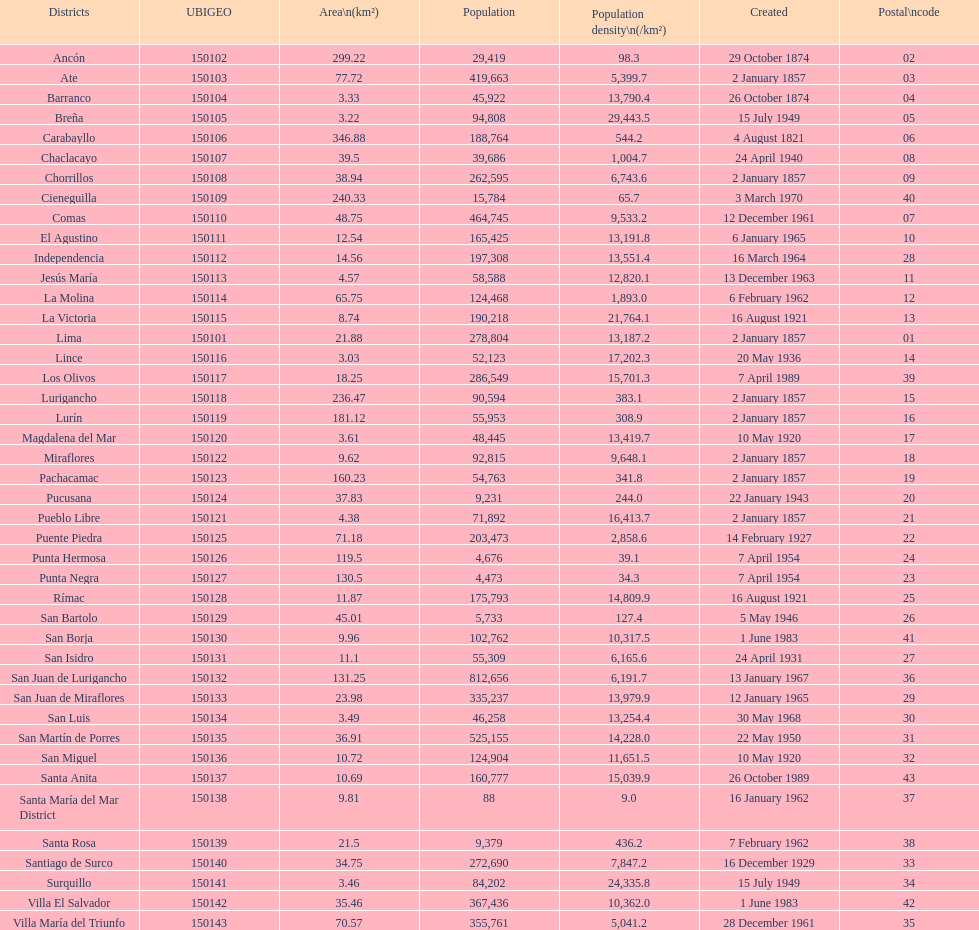I'm looking to parse the entire table for insights. Could you assist me with that? {'header': ['Districts', 'UBIGEO', 'Area\\n(km²)', 'Population', 'Population density\\n(/km²)', 'Created', 'Postal\\ncode'], 'rows': [['Ancón', '150102', '299.22', '29,419', '98.3', '29 October 1874', '02'], ['Ate', '150103', '77.72', '419,663', '5,399.7', '2 January 1857', '03'], ['Barranco', '150104', '3.33', '45,922', '13,790.4', '26 October 1874', '04'], ['Breña', '150105', '3.22', '94,808', '29,443.5', '15 July 1949', '05'], ['Carabayllo', '150106', '346.88', '188,764', '544.2', '4 August 1821', '06'], ['Chaclacayo', '150107', '39.5', '39,686', '1,004.7', '24 April 1940', '08'], ['Chorrillos', '150108', '38.94', '262,595', '6,743.6', '2 January 1857', '09'], ['Cieneguilla', '150109', '240.33', '15,784', '65.7', '3 March 1970', '40'], ['Comas', '150110', '48.75', '464,745', '9,533.2', '12 December 1961', '07'], ['El Agustino', '150111', '12.54', '165,425', '13,191.8', '6 January 1965', '10'], ['Independencia', '150112', '14.56', '197,308', '13,551.4', '16 March 1964', '28'], ['Jesús María', '150113', '4.57', '58,588', '12,820.1', '13 December 1963', '11'], ['La Molina', '150114', '65.75', '124,468', '1,893.0', '6 February 1962', '12'], ['La Victoria', '150115', '8.74', '190,218', '21,764.1', '16 August 1921', '13'], ['Lima', '150101', '21.88', '278,804', '13,187.2', '2 January 1857', '01'], ['Lince', '150116', '3.03', '52,123', '17,202.3', '20 May 1936', '14'], ['Los Olivos', '150117', '18.25', '286,549', '15,701.3', '7 April 1989', '39'], ['Lurigancho', '150118', '236.47', '90,594', '383.1', '2 January 1857', '15'], ['Lurín', '150119', '181.12', '55,953', '308.9', '2 January 1857', '16'], ['Magdalena del Mar', '150120', '3.61', '48,445', '13,419.7', '10 May 1920', '17'], ['Miraflores', '150122', '9.62', '92,815', '9,648.1', '2 January 1857', '18'], ['Pachacamac', '150123', '160.23', '54,763', '341.8', '2 January 1857', '19'], ['Pucusana', '150124', '37.83', '9,231', '244.0', '22 January 1943', '20'], ['Pueblo Libre', '150121', '4.38', '71,892', '16,413.7', '2 January 1857', '21'], ['Puente Piedra', '150125', '71.18', '203,473', '2,858.6', '14 February 1927', '22'], ['Punta Hermosa', '150126', '119.5', '4,676', '39.1', '7 April 1954', '24'], ['Punta Negra', '150127', '130.5', '4,473', '34.3', '7 April 1954', '23'], ['Rímac', '150128', '11.87', '175,793', '14,809.9', '16 August 1921', '25'], ['San Bartolo', '150129', '45.01', '5,733', '127.4', '5 May 1946', '26'], ['San Borja', '150130', '9.96', '102,762', '10,317.5', '1 June 1983', '41'], ['San Isidro', '150131', '11.1', '55,309', '6,165.6', '24 April 1931', '27'], ['San Juan de Lurigancho', '150132', '131.25', '812,656', '6,191.7', '13 January 1967', '36'], ['San Juan de Miraflores', '150133', '23.98', '335,237', '13,979.9', '12 January 1965', '29'], ['San Luis', '150134', '3.49', '46,258', '13,254.4', '30 May 1968', '30'], ['San Martín de Porres', '150135', '36.91', '525,155', '14,228.0', '22 May 1950', '31'], ['San Miguel', '150136', '10.72', '124,904', '11,651.5', '10 May 1920', '32'], ['Santa Anita', '150137', '10.69', '160,777', '15,039.9', '26 October 1989', '43'], ['Santa María del Mar District', '150138', '9.81', '88', '9.0', '16 January 1962', '37'], ['Santa Rosa', '150139', '21.5', '9,379', '436.2', '7 February 1962', '38'], ['Santiago de Surco', '150140', '34.75', '272,690', '7,847.2', '16 December 1929', '33'], ['Surquillo', '150141', '3.46', '84,202', '24,335.8', '15 July 1949', '34'], ['Villa El Salvador', '150142', '35.46', '367,436', '10,362.0', '1 June 1983', '42'], ['Villa María del Triunfo', '150143', '70.57', '355,761', '5,041.2', '28 December 1961', '35']]} What was the most recent district established? Santa Anita. 